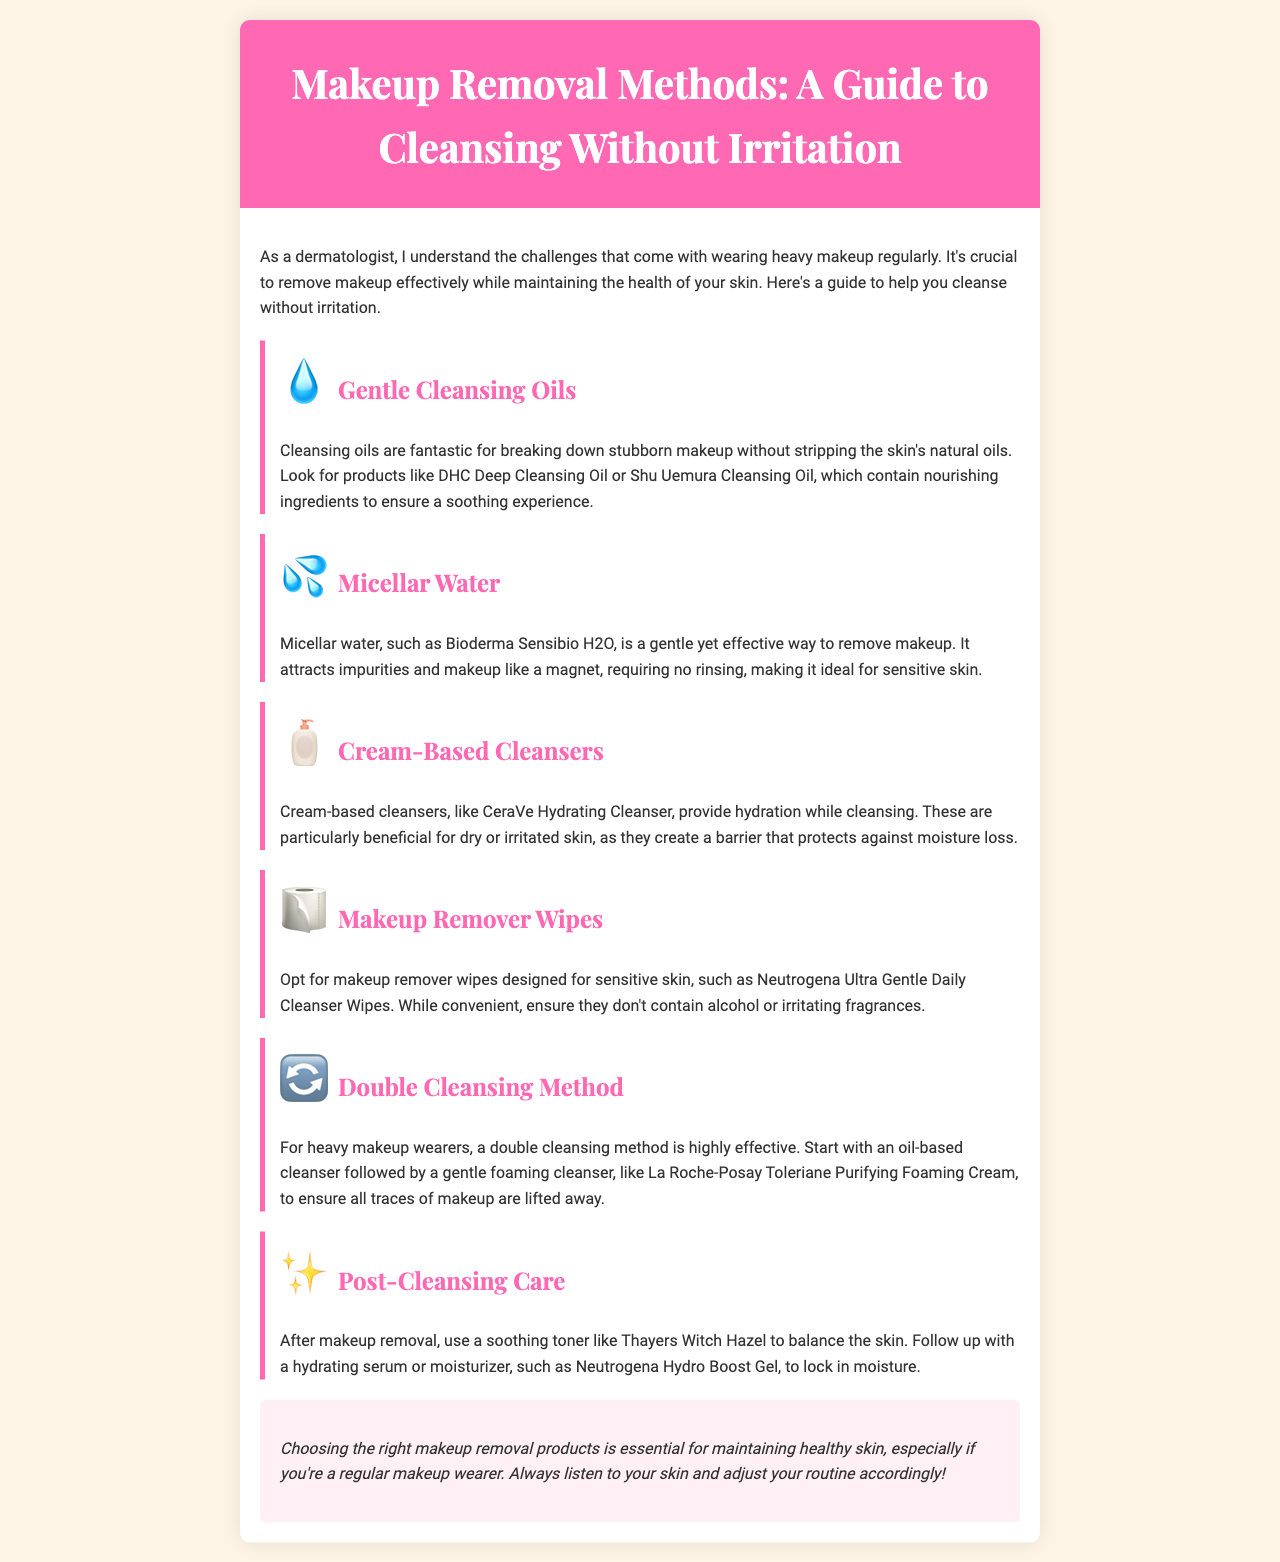What is the main purpose of the brochure? The main purpose of the brochure is to provide guidance on effective makeup removal methods while maintaining skin health.
Answer: To provide guidance on effective makeup removal methods What is the title of the first method mentioned? The first method mentioned in the brochure is "Gentle Cleansing Oils."
Answer: Gentle Cleansing Oils Which micellar water is recommended? The recommended micellar water in the brochure is Bioderma Sensibio H2O.
Answer: Bioderma Sensibio H2O What type of cleanser is CeraVe Hydrating Cleanser? CeraVe Hydrating Cleanser is classified as a cream-based cleanser according to the brochure.
Answer: Cream-based cleanser What method involves using both an oil-based cleanser and a foaming cleanser? The method that involves both is called the double cleansing method.
Answer: Double cleansing method Which product should be used after makeup removal for balancing the skin? A soothing toner like Thayers Witch Hazel should be used after makeup removal for balancing the skin.
Answer: Thayers Witch Hazel What should you look for in makeup remover wipes? You should look for makeup remover wipes designed for sensitive skin and ensure they don’t contain alcohol or irritating fragrances.
Answer: Designed for sensitive skin What does the brochure suggest for post-cleansing care? The brochure suggests using a hydrating serum or moisturizer, such as Neutrogena Hydro Boost Gel, for post-cleansing care.
Answer: Neutrogena Hydro Boost Gel 